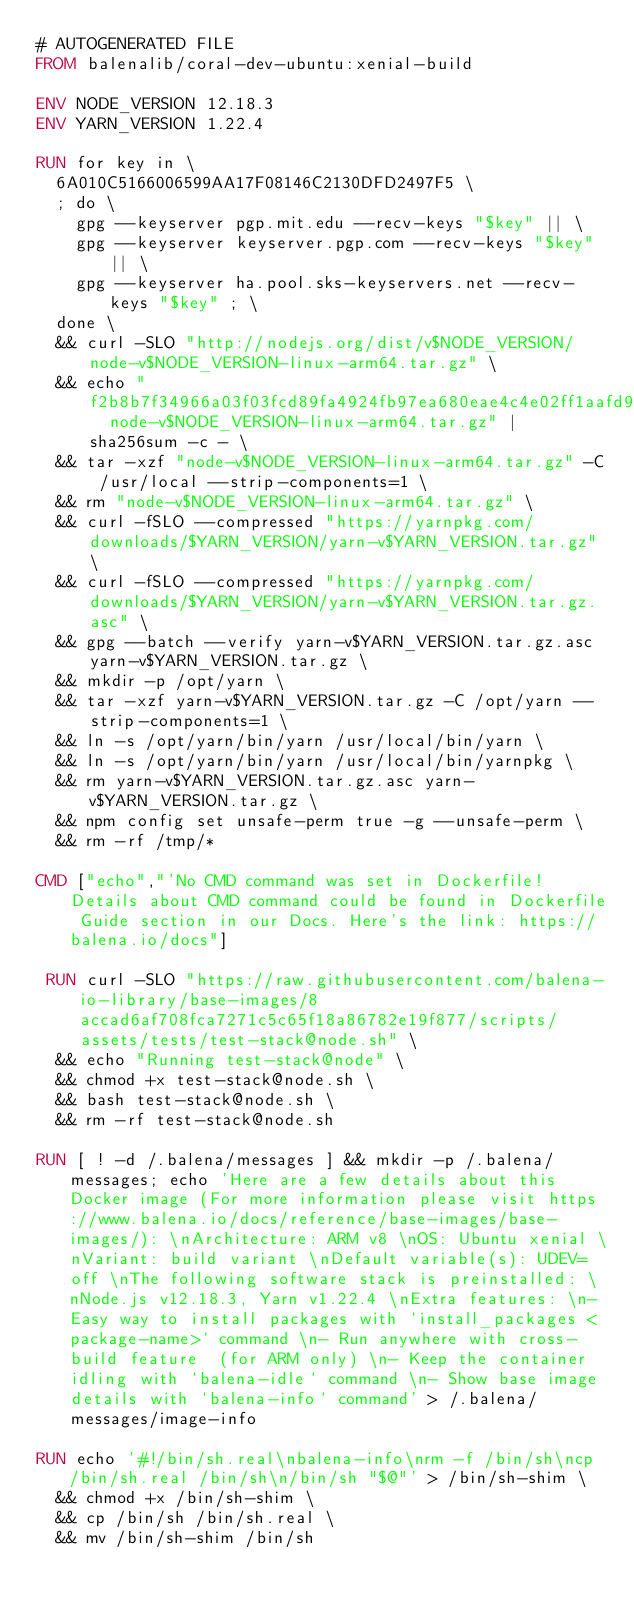<code> <loc_0><loc_0><loc_500><loc_500><_Dockerfile_># AUTOGENERATED FILE
FROM balenalib/coral-dev-ubuntu:xenial-build

ENV NODE_VERSION 12.18.3
ENV YARN_VERSION 1.22.4

RUN for key in \
	6A010C5166006599AA17F08146C2130DFD2497F5 \
	; do \
		gpg --keyserver pgp.mit.edu --recv-keys "$key" || \
		gpg --keyserver keyserver.pgp.com --recv-keys "$key" || \
		gpg --keyserver ha.pool.sks-keyservers.net --recv-keys "$key" ; \
	done \
	&& curl -SLO "http://nodejs.org/dist/v$NODE_VERSION/node-v$NODE_VERSION-linux-arm64.tar.gz" \
	&& echo "f2b8b7f34966a03f03fcd89fa4924fb97ea680eae4c4e02ff1aafd9ea89ecad8  node-v$NODE_VERSION-linux-arm64.tar.gz" | sha256sum -c - \
	&& tar -xzf "node-v$NODE_VERSION-linux-arm64.tar.gz" -C /usr/local --strip-components=1 \
	&& rm "node-v$NODE_VERSION-linux-arm64.tar.gz" \
	&& curl -fSLO --compressed "https://yarnpkg.com/downloads/$YARN_VERSION/yarn-v$YARN_VERSION.tar.gz" \
	&& curl -fSLO --compressed "https://yarnpkg.com/downloads/$YARN_VERSION/yarn-v$YARN_VERSION.tar.gz.asc" \
	&& gpg --batch --verify yarn-v$YARN_VERSION.tar.gz.asc yarn-v$YARN_VERSION.tar.gz \
	&& mkdir -p /opt/yarn \
	&& tar -xzf yarn-v$YARN_VERSION.tar.gz -C /opt/yarn --strip-components=1 \
	&& ln -s /opt/yarn/bin/yarn /usr/local/bin/yarn \
	&& ln -s /opt/yarn/bin/yarn /usr/local/bin/yarnpkg \
	&& rm yarn-v$YARN_VERSION.tar.gz.asc yarn-v$YARN_VERSION.tar.gz \
	&& npm config set unsafe-perm true -g --unsafe-perm \
	&& rm -rf /tmp/*

CMD ["echo","'No CMD command was set in Dockerfile! Details about CMD command could be found in Dockerfile Guide section in our Docs. Here's the link: https://balena.io/docs"]

 RUN curl -SLO "https://raw.githubusercontent.com/balena-io-library/base-images/8accad6af708fca7271c5c65f18a86782e19f877/scripts/assets/tests/test-stack@node.sh" \
  && echo "Running test-stack@node" \
  && chmod +x test-stack@node.sh \
  && bash test-stack@node.sh \
  && rm -rf test-stack@node.sh 

RUN [ ! -d /.balena/messages ] && mkdir -p /.balena/messages; echo 'Here are a few details about this Docker image (For more information please visit https://www.balena.io/docs/reference/base-images/base-images/): \nArchitecture: ARM v8 \nOS: Ubuntu xenial \nVariant: build variant \nDefault variable(s): UDEV=off \nThe following software stack is preinstalled: \nNode.js v12.18.3, Yarn v1.22.4 \nExtra features: \n- Easy way to install packages with `install_packages <package-name>` command \n- Run anywhere with cross-build feature  (for ARM only) \n- Keep the container idling with `balena-idle` command \n- Show base image details with `balena-info` command' > /.balena/messages/image-info

RUN echo '#!/bin/sh.real\nbalena-info\nrm -f /bin/sh\ncp /bin/sh.real /bin/sh\n/bin/sh "$@"' > /bin/sh-shim \
	&& chmod +x /bin/sh-shim \
	&& cp /bin/sh /bin/sh.real \
	&& mv /bin/sh-shim /bin/sh</code> 